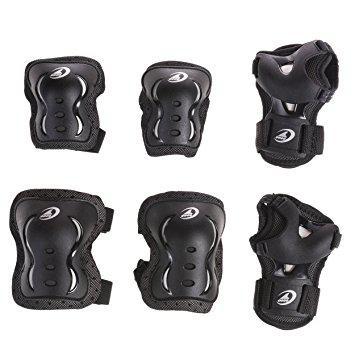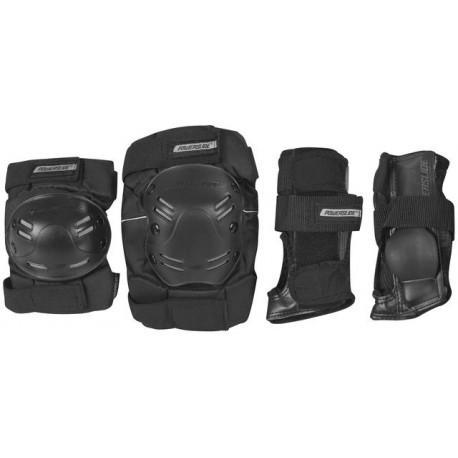The first image is the image on the left, the second image is the image on the right. Examine the images to the left and right. Is the description "there are 6 kneepads per image pair" accurate? Answer yes or no. No. The first image is the image on the left, the second image is the image on the right. For the images shown, is this caption "There are exactly six pads in total." true? Answer yes or no. No. 